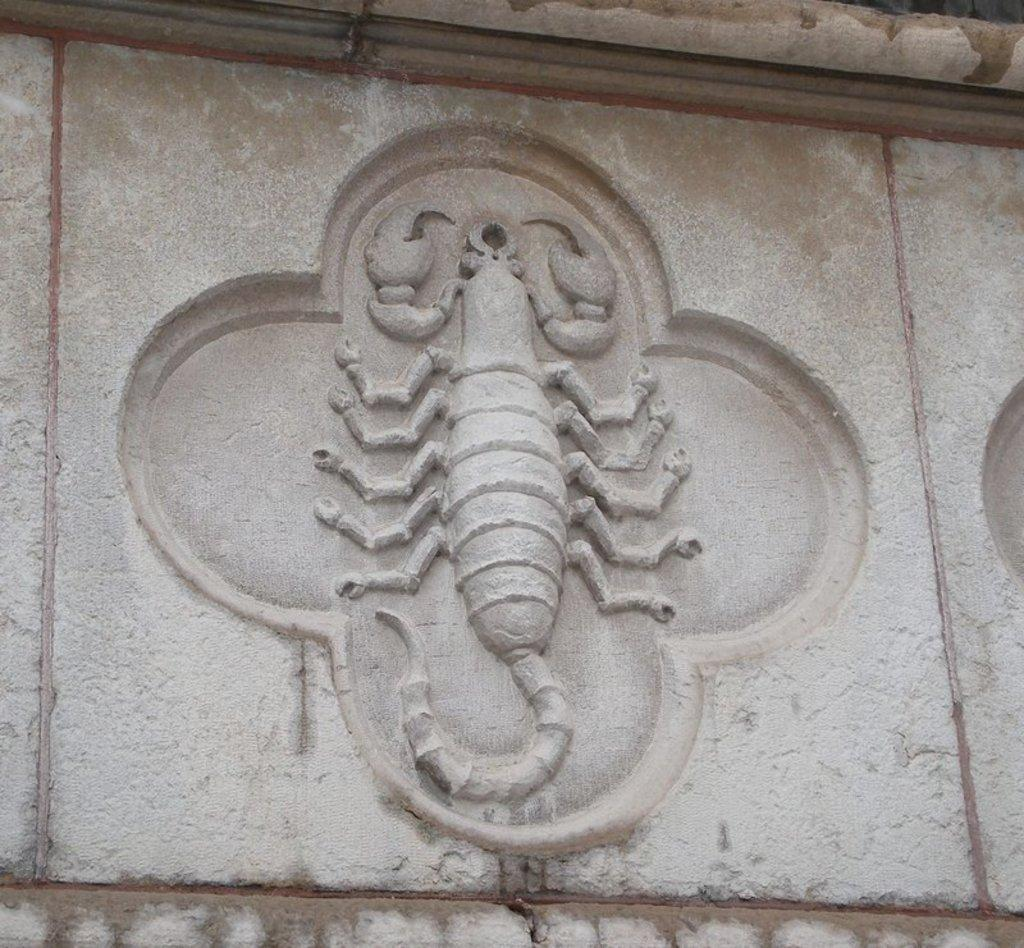What is on the wall in the image? There is a sculpture on the wall in the image. What type of advertisement can be seen on the sidewalk in the image? There is no advertisement or sidewalk present in the image; it only features a sculpture on the wall. What facial expression does the face in the image have? There is no face present in the image; it only features a sculpture on the wall. 